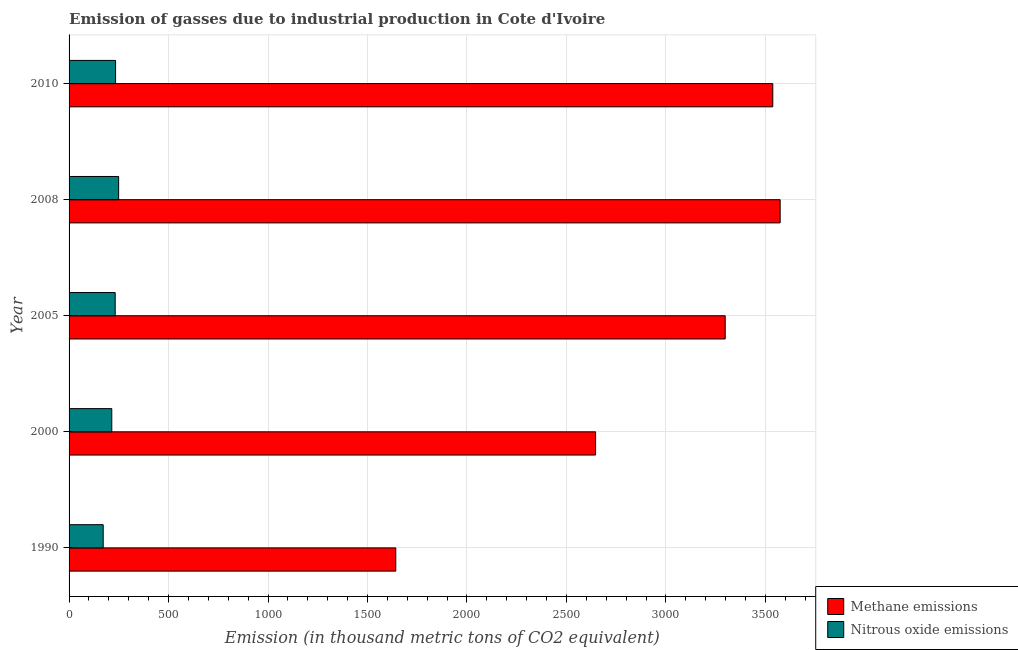Are the number of bars on each tick of the Y-axis equal?
Your answer should be compact. Yes. How many bars are there on the 4th tick from the top?
Offer a terse response. 2. In how many cases, is the number of bars for a given year not equal to the number of legend labels?
Keep it short and to the point. 0. What is the amount of nitrous oxide emissions in 2005?
Provide a short and direct response. 231.8. Across all years, what is the maximum amount of nitrous oxide emissions?
Your answer should be compact. 249.2. Across all years, what is the minimum amount of methane emissions?
Your response must be concise. 1642.3. In which year was the amount of methane emissions maximum?
Your answer should be very brief. 2008. In which year was the amount of methane emissions minimum?
Offer a terse response. 1990. What is the total amount of nitrous oxide emissions in the graph?
Offer a very short reply. 1101.1. What is the difference between the amount of nitrous oxide emissions in 2000 and that in 2005?
Provide a succinct answer. -17.1. What is the difference between the amount of methane emissions in 2008 and the amount of nitrous oxide emissions in 2010?
Provide a short and direct response. 3340.6. What is the average amount of methane emissions per year?
Offer a terse response. 2939.78. In the year 1990, what is the difference between the amount of methane emissions and amount of nitrous oxide emissions?
Offer a very short reply. 1470.7. In how many years, is the amount of methane emissions greater than 900 thousand metric tons?
Offer a very short reply. 5. What is the ratio of the amount of nitrous oxide emissions in 1990 to that in 2010?
Your answer should be compact. 0.73. Is the difference between the amount of methane emissions in 2005 and 2008 greater than the difference between the amount of nitrous oxide emissions in 2005 and 2008?
Provide a short and direct response. No. What is the difference between the highest and the second highest amount of nitrous oxide emissions?
Your answer should be very brief. 15.4. What is the difference between the highest and the lowest amount of methane emissions?
Your answer should be compact. 1932.1. What does the 2nd bar from the top in 2010 represents?
Your answer should be very brief. Methane emissions. What does the 1st bar from the bottom in 2005 represents?
Your answer should be compact. Methane emissions. Are all the bars in the graph horizontal?
Provide a short and direct response. Yes. How many years are there in the graph?
Keep it short and to the point. 5. Are the values on the major ticks of X-axis written in scientific E-notation?
Your answer should be very brief. No. Does the graph contain grids?
Provide a short and direct response. Yes. How many legend labels are there?
Offer a terse response. 2. How are the legend labels stacked?
Your response must be concise. Vertical. What is the title of the graph?
Provide a succinct answer. Emission of gasses due to industrial production in Cote d'Ivoire. What is the label or title of the X-axis?
Your answer should be compact. Emission (in thousand metric tons of CO2 equivalent). What is the label or title of the Y-axis?
Give a very brief answer. Year. What is the Emission (in thousand metric tons of CO2 equivalent) of Methane emissions in 1990?
Offer a terse response. 1642.3. What is the Emission (in thousand metric tons of CO2 equivalent) in Nitrous oxide emissions in 1990?
Offer a terse response. 171.6. What is the Emission (in thousand metric tons of CO2 equivalent) in Methane emissions in 2000?
Provide a succinct answer. 2646.7. What is the Emission (in thousand metric tons of CO2 equivalent) in Nitrous oxide emissions in 2000?
Ensure brevity in your answer.  214.7. What is the Emission (in thousand metric tons of CO2 equivalent) in Methane emissions in 2005?
Ensure brevity in your answer.  3298.2. What is the Emission (in thousand metric tons of CO2 equivalent) in Nitrous oxide emissions in 2005?
Make the answer very short. 231.8. What is the Emission (in thousand metric tons of CO2 equivalent) of Methane emissions in 2008?
Your response must be concise. 3574.4. What is the Emission (in thousand metric tons of CO2 equivalent) in Nitrous oxide emissions in 2008?
Make the answer very short. 249.2. What is the Emission (in thousand metric tons of CO2 equivalent) in Methane emissions in 2010?
Provide a succinct answer. 3537.3. What is the Emission (in thousand metric tons of CO2 equivalent) of Nitrous oxide emissions in 2010?
Your response must be concise. 233.8. Across all years, what is the maximum Emission (in thousand metric tons of CO2 equivalent) of Methane emissions?
Your answer should be very brief. 3574.4. Across all years, what is the maximum Emission (in thousand metric tons of CO2 equivalent) in Nitrous oxide emissions?
Provide a succinct answer. 249.2. Across all years, what is the minimum Emission (in thousand metric tons of CO2 equivalent) in Methane emissions?
Offer a terse response. 1642.3. Across all years, what is the minimum Emission (in thousand metric tons of CO2 equivalent) in Nitrous oxide emissions?
Make the answer very short. 171.6. What is the total Emission (in thousand metric tons of CO2 equivalent) of Methane emissions in the graph?
Provide a short and direct response. 1.47e+04. What is the total Emission (in thousand metric tons of CO2 equivalent) of Nitrous oxide emissions in the graph?
Your response must be concise. 1101.1. What is the difference between the Emission (in thousand metric tons of CO2 equivalent) in Methane emissions in 1990 and that in 2000?
Keep it short and to the point. -1004.4. What is the difference between the Emission (in thousand metric tons of CO2 equivalent) in Nitrous oxide emissions in 1990 and that in 2000?
Your answer should be compact. -43.1. What is the difference between the Emission (in thousand metric tons of CO2 equivalent) in Methane emissions in 1990 and that in 2005?
Your answer should be compact. -1655.9. What is the difference between the Emission (in thousand metric tons of CO2 equivalent) in Nitrous oxide emissions in 1990 and that in 2005?
Your answer should be compact. -60.2. What is the difference between the Emission (in thousand metric tons of CO2 equivalent) of Methane emissions in 1990 and that in 2008?
Your response must be concise. -1932.1. What is the difference between the Emission (in thousand metric tons of CO2 equivalent) in Nitrous oxide emissions in 1990 and that in 2008?
Offer a terse response. -77.6. What is the difference between the Emission (in thousand metric tons of CO2 equivalent) of Methane emissions in 1990 and that in 2010?
Your response must be concise. -1895. What is the difference between the Emission (in thousand metric tons of CO2 equivalent) of Nitrous oxide emissions in 1990 and that in 2010?
Ensure brevity in your answer.  -62.2. What is the difference between the Emission (in thousand metric tons of CO2 equivalent) in Methane emissions in 2000 and that in 2005?
Offer a very short reply. -651.5. What is the difference between the Emission (in thousand metric tons of CO2 equivalent) in Nitrous oxide emissions in 2000 and that in 2005?
Your answer should be compact. -17.1. What is the difference between the Emission (in thousand metric tons of CO2 equivalent) of Methane emissions in 2000 and that in 2008?
Your response must be concise. -927.7. What is the difference between the Emission (in thousand metric tons of CO2 equivalent) of Nitrous oxide emissions in 2000 and that in 2008?
Offer a very short reply. -34.5. What is the difference between the Emission (in thousand metric tons of CO2 equivalent) in Methane emissions in 2000 and that in 2010?
Your response must be concise. -890.6. What is the difference between the Emission (in thousand metric tons of CO2 equivalent) of Nitrous oxide emissions in 2000 and that in 2010?
Give a very brief answer. -19.1. What is the difference between the Emission (in thousand metric tons of CO2 equivalent) in Methane emissions in 2005 and that in 2008?
Offer a terse response. -276.2. What is the difference between the Emission (in thousand metric tons of CO2 equivalent) in Nitrous oxide emissions in 2005 and that in 2008?
Provide a succinct answer. -17.4. What is the difference between the Emission (in thousand metric tons of CO2 equivalent) in Methane emissions in 2005 and that in 2010?
Offer a very short reply. -239.1. What is the difference between the Emission (in thousand metric tons of CO2 equivalent) of Nitrous oxide emissions in 2005 and that in 2010?
Your answer should be compact. -2. What is the difference between the Emission (in thousand metric tons of CO2 equivalent) of Methane emissions in 2008 and that in 2010?
Keep it short and to the point. 37.1. What is the difference between the Emission (in thousand metric tons of CO2 equivalent) in Methane emissions in 1990 and the Emission (in thousand metric tons of CO2 equivalent) in Nitrous oxide emissions in 2000?
Your answer should be compact. 1427.6. What is the difference between the Emission (in thousand metric tons of CO2 equivalent) in Methane emissions in 1990 and the Emission (in thousand metric tons of CO2 equivalent) in Nitrous oxide emissions in 2005?
Your response must be concise. 1410.5. What is the difference between the Emission (in thousand metric tons of CO2 equivalent) in Methane emissions in 1990 and the Emission (in thousand metric tons of CO2 equivalent) in Nitrous oxide emissions in 2008?
Make the answer very short. 1393.1. What is the difference between the Emission (in thousand metric tons of CO2 equivalent) in Methane emissions in 1990 and the Emission (in thousand metric tons of CO2 equivalent) in Nitrous oxide emissions in 2010?
Make the answer very short. 1408.5. What is the difference between the Emission (in thousand metric tons of CO2 equivalent) in Methane emissions in 2000 and the Emission (in thousand metric tons of CO2 equivalent) in Nitrous oxide emissions in 2005?
Your answer should be very brief. 2414.9. What is the difference between the Emission (in thousand metric tons of CO2 equivalent) in Methane emissions in 2000 and the Emission (in thousand metric tons of CO2 equivalent) in Nitrous oxide emissions in 2008?
Your response must be concise. 2397.5. What is the difference between the Emission (in thousand metric tons of CO2 equivalent) in Methane emissions in 2000 and the Emission (in thousand metric tons of CO2 equivalent) in Nitrous oxide emissions in 2010?
Your response must be concise. 2412.9. What is the difference between the Emission (in thousand metric tons of CO2 equivalent) of Methane emissions in 2005 and the Emission (in thousand metric tons of CO2 equivalent) of Nitrous oxide emissions in 2008?
Provide a short and direct response. 3049. What is the difference between the Emission (in thousand metric tons of CO2 equivalent) of Methane emissions in 2005 and the Emission (in thousand metric tons of CO2 equivalent) of Nitrous oxide emissions in 2010?
Give a very brief answer. 3064.4. What is the difference between the Emission (in thousand metric tons of CO2 equivalent) of Methane emissions in 2008 and the Emission (in thousand metric tons of CO2 equivalent) of Nitrous oxide emissions in 2010?
Your answer should be very brief. 3340.6. What is the average Emission (in thousand metric tons of CO2 equivalent) of Methane emissions per year?
Offer a terse response. 2939.78. What is the average Emission (in thousand metric tons of CO2 equivalent) of Nitrous oxide emissions per year?
Provide a short and direct response. 220.22. In the year 1990, what is the difference between the Emission (in thousand metric tons of CO2 equivalent) of Methane emissions and Emission (in thousand metric tons of CO2 equivalent) of Nitrous oxide emissions?
Keep it short and to the point. 1470.7. In the year 2000, what is the difference between the Emission (in thousand metric tons of CO2 equivalent) of Methane emissions and Emission (in thousand metric tons of CO2 equivalent) of Nitrous oxide emissions?
Offer a terse response. 2432. In the year 2005, what is the difference between the Emission (in thousand metric tons of CO2 equivalent) in Methane emissions and Emission (in thousand metric tons of CO2 equivalent) in Nitrous oxide emissions?
Keep it short and to the point. 3066.4. In the year 2008, what is the difference between the Emission (in thousand metric tons of CO2 equivalent) in Methane emissions and Emission (in thousand metric tons of CO2 equivalent) in Nitrous oxide emissions?
Your response must be concise. 3325.2. In the year 2010, what is the difference between the Emission (in thousand metric tons of CO2 equivalent) of Methane emissions and Emission (in thousand metric tons of CO2 equivalent) of Nitrous oxide emissions?
Provide a succinct answer. 3303.5. What is the ratio of the Emission (in thousand metric tons of CO2 equivalent) in Methane emissions in 1990 to that in 2000?
Your answer should be compact. 0.62. What is the ratio of the Emission (in thousand metric tons of CO2 equivalent) in Nitrous oxide emissions in 1990 to that in 2000?
Make the answer very short. 0.8. What is the ratio of the Emission (in thousand metric tons of CO2 equivalent) of Methane emissions in 1990 to that in 2005?
Your answer should be very brief. 0.5. What is the ratio of the Emission (in thousand metric tons of CO2 equivalent) in Nitrous oxide emissions in 1990 to that in 2005?
Make the answer very short. 0.74. What is the ratio of the Emission (in thousand metric tons of CO2 equivalent) of Methane emissions in 1990 to that in 2008?
Give a very brief answer. 0.46. What is the ratio of the Emission (in thousand metric tons of CO2 equivalent) in Nitrous oxide emissions in 1990 to that in 2008?
Offer a terse response. 0.69. What is the ratio of the Emission (in thousand metric tons of CO2 equivalent) of Methane emissions in 1990 to that in 2010?
Provide a succinct answer. 0.46. What is the ratio of the Emission (in thousand metric tons of CO2 equivalent) of Nitrous oxide emissions in 1990 to that in 2010?
Ensure brevity in your answer.  0.73. What is the ratio of the Emission (in thousand metric tons of CO2 equivalent) of Methane emissions in 2000 to that in 2005?
Offer a very short reply. 0.8. What is the ratio of the Emission (in thousand metric tons of CO2 equivalent) in Nitrous oxide emissions in 2000 to that in 2005?
Give a very brief answer. 0.93. What is the ratio of the Emission (in thousand metric tons of CO2 equivalent) in Methane emissions in 2000 to that in 2008?
Your answer should be compact. 0.74. What is the ratio of the Emission (in thousand metric tons of CO2 equivalent) in Nitrous oxide emissions in 2000 to that in 2008?
Offer a very short reply. 0.86. What is the ratio of the Emission (in thousand metric tons of CO2 equivalent) of Methane emissions in 2000 to that in 2010?
Give a very brief answer. 0.75. What is the ratio of the Emission (in thousand metric tons of CO2 equivalent) in Nitrous oxide emissions in 2000 to that in 2010?
Your answer should be very brief. 0.92. What is the ratio of the Emission (in thousand metric tons of CO2 equivalent) in Methane emissions in 2005 to that in 2008?
Your answer should be very brief. 0.92. What is the ratio of the Emission (in thousand metric tons of CO2 equivalent) in Nitrous oxide emissions in 2005 to that in 2008?
Offer a terse response. 0.93. What is the ratio of the Emission (in thousand metric tons of CO2 equivalent) in Methane emissions in 2005 to that in 2010?
Your answer should be compact. 0.93. What is the ratio of the Emission (in thousand metric tons of CO2 equivalent) in Nitrous oxide emissions in 2005 to that in 2010?
Give a very brief answer. 0.99. What is the ratio of the Emission (in thousand metric tons of CO2 equivalent) in Methane emissions in 2008 to that in 2010?
Make the answer very short. 1.01. What is the ratio of the Emission (in thousand metric tons of CO2 equivalent) of Nitrous oxide emissions in 2008 to that in 2010?
Provide a short and direct response. 1.07. What is the difference between the highest and the second highest Emission (in thousand metric tons of CO2 equivalent) of Methane emissions?
Provide a short and direct response. 37.1. What is the difference between the highest and the lowest Emission (in thousand metric tons of CO2 equivalent) in Methane emissions?
Your answer should be compact. 1932.1. What is the difference between the highest and the lowest Emission (in thousand metric tons of CO2 equivalent) of Nitrous oxide emissions?
Provide a short and direct response. 77.6. 